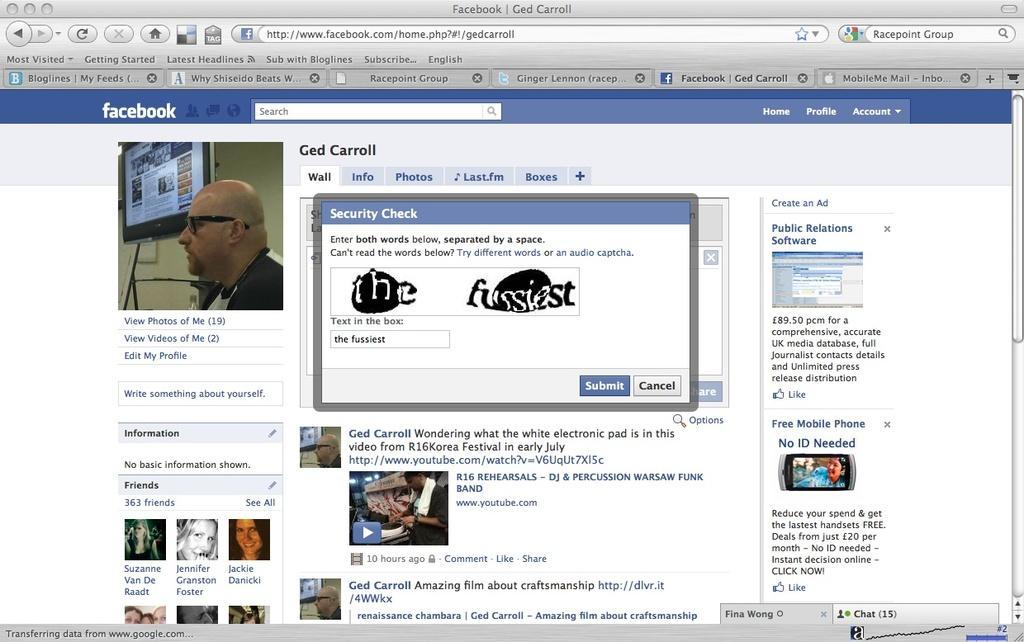Please provide a concise description of this image. In this image we can see the screen of a computer where we can see the profile page of a person's Facebook and we can see his picture, dialogue box, posts, URL and chat notification. 